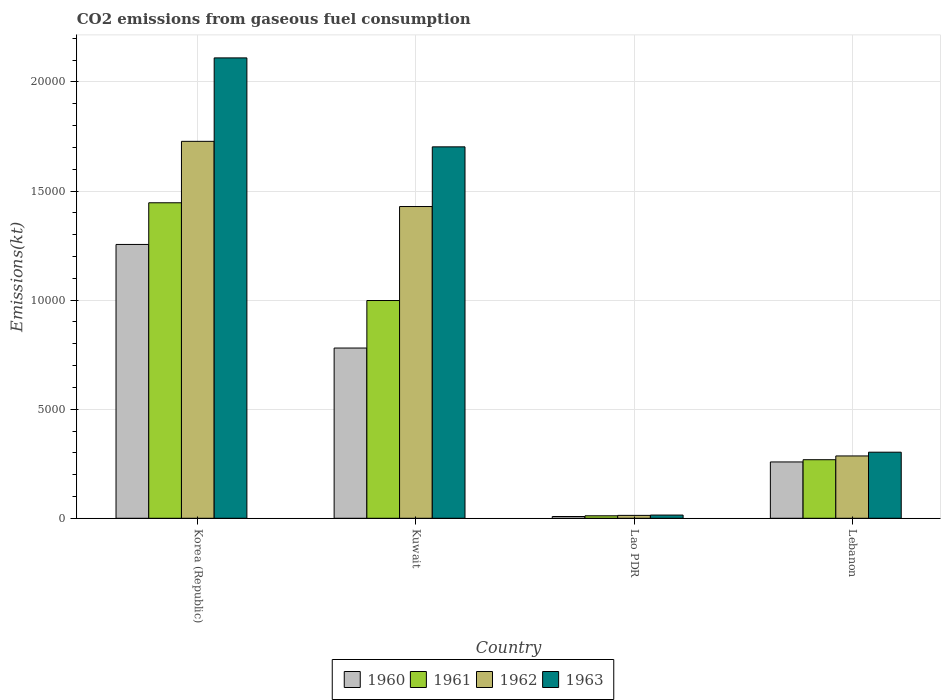How many bars are there on the 2nd tick from the left?
Keep it short and to the point. 4. What is the label of the 1st group of bars from the left?
Give a very brief answer. Korea (Republic). What is the amount of CO2 emitted in 1963 in Kuwait?
Ensure brevity in your answer.  1.70e+04. Across all countries, what is the maximum amount of CO2 emitted in 1963?
Provide a short and direct response. 2.11e+04. Across all countries, what is the minimum amount of CO2 emitted in 1962?
Keep it short and to the point. 132.01. In which country was the amount of CO2 emitted in 1963 maximum?
Keep it short and to the point. Korea (Republic). In which country was the amount of CO2 emitted in 1961 minimum?
Ensure brevity in your answer.  Lao PDR. What is the total amount of CO2 emitted in 1960 in the graph?
Keep it short and to the point. 2.30e+04. What is the difference between the amount of CO2 emitted in 1963 in Korea (Republic) and that in Kuwait?
Keep it short and to the point. 4077.7. What is the difference between the amount of CO2 emitted in 1960 in Kuwait and the amount of CO2 emitted in 1962 in Lebanon?
Offer a very short reply. 4946.78. What is the average amount of CO2 emitted in 1960 per country?
Give a very brief answer. 5754.44. What is the difference between the amount of CO2 emitted of/in 1963 and amount of CO2 emitted of/in 1962 in Lebanon?
Keep it short and to the point. 172.35. What is the ratio of the amount of CO2 emitted in 1961 in Kuwait to that in Lao PDR?
Provide a succinct answer. 87.81. What is the difference between the highest and the second highest amount of CO2 emitted in 1963?
Keep it short and to the point. 1.40e+04. What is the difference between the highest and the lowest amount of CO2 emitted in 1960?
Your response must be concise. 1.25e+04. In how many countries, is the amount of CO2 emitted in 1963 greater than the average amount of CO2 emitted in 1963 taken over all countries?
Provide a succinct answer. 2. Is the sum of the amount of CO2 emitted in 1960 in Korea (Republic) and Lao PDR greater than the maximum amount of CO2 emitted in 1963 across all countries?
Your response must be concise. No. Is it the case that in every country, the sum of the amount of CO2 emitted in 1963 and amount of CO2 emitted in 1962 is greater than the sum of amount of CO2 emitted in 1960 and amount of CO2 emitted in 1961?
Offer a very short reply. No. Is it the case that in every country, the sum of the amount of CO2 emitted in 1960 and amount of CO2 emitted in 1961 is greater than the amount of CO2 emitted in 1962?
Give a very brief answer. Yes. Are all the bars in the graph horizontal?
Provide a short and direct response. No. How many countries are there in the graph?
Make the answer very short. 4. Are the values on the major ticks of Y-axis written in scientific E-notation?
Provide a short and direct response. No. Does the graph contain any zero values?
Provide a short and direct response. No. How are the legend labels stacked?
Make the answer very short. Horizontal. What is the title of the graph?
Offer a terse response. CO2 emissions from gaseous fuel consumption. What is the label or title of the Y-axis?
Provide a succinct answer. Emissions(kt). What is the Emissions(kt) in 1960 in Korea (Republic)?
Keep it short and to the point. 1.26e+04. What is the Emissions(kt) of 1961 in Korea (Republic)?
Offer a very short reply. 1.45e+04. What is the Emissions(kt) in 1962 in Korea (Republic)?
Your response must be concise. 1.73e+04. What is the Emissions(kt) in 1963 in Korea (Republic)?
Ensure brevity in your answer.  2.11e+04. What is the Emissions(kt) in 1960 in Kuwait?
Your answer should be very brief. 7803.38. What is the Emissions(kt) of 1961 in Kuwait?
Provide a succinct answer. 9981.57. What is the Emissions(kt) in 1962 in Kuwait?
Give a very brief answer. 1.43e+04. What is the Emissions(kt) of 1963 in Kuwait?
Provide a short and direct response. 1.70e+04. What is the Emissions(kt) in 1960 in Lao PDR?
Make the answer very short. 80.67. What is the Emissions(kt) of 1961 in Lao PDR?
Your response must be concise. 113.68. What is the Emissions(kt) of 1962 in Lao PDR?
Ensure brevity in your answer.  132.01. What is the Emissions(kt) of 1963 in Lao PDR?
Make the answer very short. 146.68. What is the Emissions(kt) in 1960 in Lebanon?
Offer a terse response. 2581.57. What is the Emissions(kt) of 1961 in Lebanon?
Offer a terse response. 2684.24. What is the Emissions(kt) of 1962 in Lebanon?
Ensure brevity in your answer.  2856.59. What is the Emissions(kt) in 1963 in Lebanon?
Provide a short and direct response. 3028.94. Across all countries, what is the maximum Emissions(kt) in 1960?
Offer a terse response. 1.26e+04. Across all countries, what is the maximum Emissions(kt) of 1961?
Your answer should be compact. 1.45e+04. Across all countries, what is the maximum Emissions(kt) in 1962?
Your answer should be very brief. 1.73e+04. Across all countries, what is the maximum Emissions(kt) in 1963?
Your answer should be very brief. 2.11e+04. Across all countries, what is the minimum Emissions(kt) in 1960?
Ensure brevity in your answer.  80.67. Across all countries, what is the minimum Emissions(kt) in 1961?
Your answer should be compact. 113.68. Across all countries, what is the minimum Emissions(kt) in 1962?
Ensure brevity in your answer.  132.01. Across all countries, what is the minimum Emissions(kt) in 1963?
Offer a very short reply. 146.68. What is the total Emissions(kt) in 1960 in the graph?
Give a very brief answer. 2.30e+04. What is the total Emissions(kt) of 1961 in the graph?
Ensure brevity in your answer.  2.72e+04. What is the total Emissions(kt) in 1962 in the graph?
Give a very brief answer. 3.46e+04. What is the total Emissions(kt) in 1963 in the graph?
Your response must be concise. 4.13e+04. What is the difference between the Emissions(kt) of 1960 in Korea (Republic) and that in Kuwait?
Offer a very short reply. 4748.77. What is the difference between the Emissions(kt) in 1961 in Korea (Republic) and that in Kuwait?
Provide a short and direct response. 4481.07. What is the difference between the Emissions(kt) of 1962 in Korea (Republic) and that in Kuwait?
Provide a succinct answer. 2988.61. What is the difference between the Emissions(kt) in 1963 in Korea (Republic) and that in Kuwait?
Give a very brief answer. 4077.7. What is the difference between the Emissions(kt) of 1960 in Korea (Republic) and that in Lao PDR?
Offer a very short reply. 1.25e+04. What is the difference between the Emissions(kt) of 1961 in Korea (Republic) and that in Lao PDR?
Your answer should be very brief. 1.43e+04. What is the difference between the Emissions(kt) in 1962 in Korea (Republic) and that in Lao PDR?
Provide a succinct answer. 1.71e+04. What is the difference between the Emissions(kt) in 1963 in Korea (Republic) and that in Lao PDR?
Your answer should be very brief. 2.10e+04. What is the difference between the Emissions(kt) of 1960 in Korea (Republic) and that in Lebanon?
Give a very brief answer. 9970.57. What is the difference between the Emissions(kt) of 1961 in Korea (Republic) and that in Lebanon?
Ensure brevity in your answer.  1.18e+04. What is the difference between the Emissions(kt) of 1962 in Korea (Republic) and that in Lebanon?
Offer a very short reply. 1.44e+04. What is the difference between the Emissions(kt) in 1963 in Korea (Republic) and that in Lebanon?
Provide a succinct answer. 1.81e+04. What is the difference between the Emissions(kt) in 1960 in Kuwait and that in Lao PDR?
Make the answer very short. 7722.7. What is the difference between the Emissions(kt) in 1961 in Kuwait and that in Lao PDR?
Provide a succinct answer. 9867.9. What is the difference between the Emissions(kt) in 1962 in Kuwait and that in Lao PDR?
Offer a terse response. 1.42e+04. What is the difference between the Emissions(kt) of 1963 in Kuwait and that in Lao PDR?
Give a very brief answer. 1.69e+04. What is the difference between the Emissions(kt) in 1960 in Kuwait and that in Lebanon?
Give a very brief answer. 5221.81. What is the difference between the Emissions(kt) in 1961 in Kuwait and that in Lebanon?
Your response must be concise. 7297.33. What is the difference between the Emissions(kt) of 1962 in Kuwait and that in Lebanon?
Provide a short and direct response. 1.14e+04. What is the difference between the Emissions(kt) in 1963 in Kuwait and that in Lebanon?
Give a very brief answer. 1.40e+04. What is the difference between the Emissions(kt) of 1960 in Lao PDR and that in Lebanon?
Give a very brief answer. -2500.89. What is the difference between the Emissions(kt) in 1961 in Lao PDR and that in Lebanon?
Ensure brevity in your answer.  -2570.57. What is the difference between the Emissions(kt) of 1962 in Lao PDR and that in Lebanon?
Provide a succinct answer. -2724.58. What is the difference between the Emissions(kt) of 1963 in Lao PDR and that in Lebanon?
Provide a succinct answer. -2882.26. What is the difference between the Emissions(kt) in 1960 in Korea (Republic) and the Emissions(kt) in 1961 in Kuwait?
Offer a very short reply. 2570.57. What is the difference between the Emissions(kt) in 1960 in Korea (Republic) and the Emissions(kt) in 1962 in Kuwait?
Make the answer very short. -1738.16. What is the difference between the Emissions(kt) of 1960 in Korea (Republic) and the Emissions(kt) of 1963 in Kuwait?
Your answer should be very brief. -4473.74. What is the difference between the Emissions(kt) in 1961 in Korea (Republic) and the Emissions(kt) in 1962 in Kuwait?
Provide a short and direct response. 172.35. What is the difference between the Emissions(kt) of 1961 in Korea (Republic) and the Emissions(kt) of 1963 in Kuwait?
Your answer should be compact. -2563.23. What is the difference between the Emissions(kt) in 1962 in Korea (Republic) and the Emissions(kt) in 1963 in Kuwait?
Provide a short and direct response. 253.02. What is the difference between the Emissions(kt) of 1960 in Korea (Republic) and the Emissions(kt) of 1961 in Lao PDR?
Provide a succinct answer. 1.24e+04. What is the difference between the Emissions(kt) in 1960 in Korea (Republic) and the Emissions(kt) in 1962 in Lao PDR?
Provide a succinct answer. 1.24e+04. What is the difference between the Emissions(kt) of 1960 in Korea (Republic) and the Emissions(kt) of 1963 in Lao PDR?
Make the answer very short. 1.24e+04. What is the difference between the Emissions(kt) in 1961 in Korea (Republic) and the Emissions(kt) in 1962 in Lao PDR?
Your answer should be compact. 1.43e+04. What is the difference between the Emissions(kt) of 1961 in Korea (Republic) and the Emissions(kt) of 1963 in Lao PDR?
Make the answer very short. 1.43e+04. What is the difference between the Emissions(kt) in 1962 in Korea (Republic) and the Emissions(kt) in 1963 in Lao PDR?
Give a very brief answer. 1.71e+04. What is the difference between the Emissions(kt) of 1960 in Korea (Republic) and the Emissions(kt) of 1961 in Lebanon?
Ensure brevity in your answer.  9867.9. What is the difference between the Emissions(kt) in 1960 in Korea (Republic) and the Emissions(kt) in 1962 in Lebanon?
Give a very brief answer. 9695.55. What is the difference between the Emissions(kt) of 1960 in Korea (Republic) and the Emissions(kt) of 1963 in Lebanon?
Offer a very short reply. 9523.2. What is the difference between the Emissions(kt) in 1961 in Korea (Republic) and the Emissions(kt) in 1962 in Lebanon?
Provide a short and direct response. 1.16e+04. What is the difference between the Emissions(kt) in 1961 in Korea (Republic) and the Emissions(kt) in 1963 in Lebanon?
Keep it short and to the point. 1.14e+04. What is the difference between the Emissions(kt) in 1962 in Korea (Republic) and the Emissions(kt) in 1963 in Lebanon?
Keep it short and to the point. 1.42e+04. What is the difference between the Emissions(kt) in 1960 in Kuwait and the Emissions(kt) in 1961 in Lao PDR?
Offer a terse response. 7689.7. What is the difference between the Emissions(kt) in 1960 in Kuwait and the Emissions(kt) in 1962 in Lao PDR?
Your response must be concise. 7671.36. What is the difference between the Emissions(kt) of 1960 in Kuwait and the Emissions(kt) of 1963 in Lao PDR?
Make the answer very short. 7656.7. What is the difference between the Emissions(kt) in 1961 in Kuwait and the Emissions(kt) in 1962 in Lao PDR?
Your answer should be compact. 9849.56. What is the difference between the Emissions(kt) in 1961 in Kuwait and the Emissions(kt) in 1963 in Lao PDR?
Your response must be concise. 9834.89. What is the difference between the Emissions(kt) of 1962 in Kuwait and the Emissions(kt) of 1963 in Lao PDR?
Provide a succinct answer. 1.41e+04. What is the difference between the Emissions(kt) in 1960 in Kuwait and the Emissions(kt) in 1961 in Lebanon?
Offer a very short reply. 5119.13. What is the difference between the Emissions(kt) in 1960 in Kuwait and the Emissions(kt) in 1962 in Lebanon?
Keep it short and to the point. 4946.78. What is the difference between the Emissions(kt) of 1960 in Kuwait and the Emissions(kt) of 1963 in Lebanon?
Give a very brief answer. 4774.43. What is the difference between the Emissions(kt) of 1961 in Kuwait and the Emissions(kt) of 1962 in Lebanon?
Offer a very short reply. 7124.98. What is the difference between the Emissions(kt) of 1961 in Kuwait and the Emissions(kt) of 1963 in Lebanon?
Make the answer very short. 6952.63. What is the difference between the Emissions(kt) in 1962 in Kuwait and the Emissions(kt) in 1963 in Lebanon?
Provide a short and direct response. 1.13e+04. What is the difference between the Emissions(kt) in 1960 in Lao PDR and the Emissions(kt) in 1961 in Lebanon?
Make the answer very short. -2603.57. What is the difference between the Emissions(kt) in 1960 in Lao PDR and the Emissions(kt) in 1962 in Lebanon?
Provide a short and direct response. -2775.92. What is the difference between the Emissions(kt) of 1960 in Lao PDR and the Emissions(kt) of 1963 in Lebanon?
Offer a terse response. -2948.27. What is the difference between the Emissions(kt) of 1961 in Lao PDR and the Emissions(kt) of 1962 in Lebanon?
Offer a terse response. -2742.92. What is the difference between the Emissions(kt) of 1961 in Lao PDR and the Emissions(kt) of 1963 in Lebanon?
Provide a short and direct response. -2915.26. What is the difference between the Emissions(kt) of 1962 in Lao PDR and the Emissions(kt) of 1963 in Lebanon?
Provide a succinct answer. -2896.93. What is the average Emissions(kt) of 1960 per country?
Your answer should be very brief. 5754.44. What is the average Emissions(kt) in 1961 per country?
Make the answer very short. 6810.54. What is the average Emissions(kt) of 1962 per country?
Provide a short and direct response. 8639.45. What is the average Emissions(kt) in 1963 per country?
Ensure brevity in your answer.  1.03e+04. What is the difference between the Emissions(kt) in 1960 and Emissions(kt) in 1961 in Korea (Republic)?
Your answer should be very brief. -1910.51. What is the difference between the Emissions(kt) in 1960 and Emissions(kt) in 1962 in Korea (Republic)?
Provide a succinct answer. -4726.76. What is the difference between the Emissions(kt) of 1960 and Emissions(kt) of 1963 in Korea (Republic)?
Make the answer very short. -8551.44. What is the difference between the Emissions(kt) in 1961 and Emissions(kt) in 1962 in Korea (Republic)?
Provide a short and direct response. -2816.26. What is the difference between the Emissions(kt) in 1961 and Emissions(kt) in 1963 in Korea (Republic)?
Ensure brevity in your answer.  -6640.94. What is the difference between the Emissions(kt) in 1962 and Emissions(kt) in 1963 in Korea (Republic)?
Your answer should be very brief. -3824.68. What is the difference between the Emissions(kt) in 1960 and Emissions(kt) in 1961 in Kuwait?
Your response must be concise. -2178.2. What is the difference between the Emissions(kt) of 1960 and Emissions(kt) of 1962 in Kuwait?
Ensure brevity in your answer.  -6486.92. What is the difference between the Emissions(kt) of 1960 and Emissions(kt) of 1963 in Kuwait?
Make the answer very short. -9222.5. What is the difference between the Emissions(kt) of 1961 and Emissions(kt) of 1962 in Kuwait?
Your answer should be compact. -4308.73. What is the difference between the Emissions(kt) of 1961 and Emissions(kt) of 1963 in Kuwait?
Offer a terse response. -7044.31. What is the difference between the Emissions(kt) in 1962 and Emissions(kt) in 1963 in Kuwait?
Offer a very short reply. -2735.58. What is the difference between the Emissions(kt) in 1960 and Emissions(kt) in 1961 in Lao PDR?
Your answer should be very brief. -33. What is the difference between the Emissions(kt) in 1960 and Emissions(kt) in 1962 in Lao PDR?
Your answer should be compact. -51.34. What is the difference between the Emissions(kt) in 1960 and Emissions(kt) in 1963 in Lao PDR?
Make the answer very short. -66.01. What is the difference between the Emissions(kt) of 1961 and Emissions(kt) of 1962 in Lao PDR?
Keep it short and to the point. -18.34. What is the difference between the Emissions(kt) of 1961 and Emissions(kt) of 1963 in Lao PDR?
Make the answer very short. -33. What is the difference between the Emissions(kt) of 1962 and Emissions(kt) of 1963 in Lao PDR?
Your answer should be compact. -14.67. What is the difference between the Emissions(kt) in 1960 and Emissions(kt) in 1961 in Lebanon?
Give a very brief answer. -102.68. What is the difference between the Emissions(kt) of 1960 and Emissions(kt) of 1962 in Lebanon?
Your response must be concise. -275.02. What is the difference between the Emissions(kt) in 1960 and Emissions(kt) in 1963 in Lebanon?
Ensure brevity in your answer.  -447.37. What is the difference between the Emissions(kt) in 1961 and Emissions(kt) in 1962 in Lebanon?
Provide a short and direct response. -172.35. What is the difference between the Emissions(kt) in 1961 and Emissions(kt) in 1963 in Lebanon?
Make the answer very short. -344.7. What is the difference between the Emissions(kt) in 1962 and Emissions(kt) in 1963 in Lebanon?
Ensure brevity in your answer.  -172.35. What is the ratio of the Emissions(kt) of 1960 in Korea (Republic) to that in Kuwait?
Your response must be concise. 1.61. What is the ratio of the Emissions(kt) of 1961 in Korea (Republic) to that in Kuwait?
Keep it short and to the point. 1.45. What is the ratio of the Emissions(kt) in 1962 in Korea (Republic) to that in Kuwait?
Offer a very short reply. 1.21. What is the ratio of the Emissions(kt) in 1963 in Korea (Republic) to that in Kuwait?
Give a very brief answer. 1.24. What is the ratio of the Emissions(kt) of 1960 in Korea (Republic) to that in Lao PDR?
Your response must be concise. 155.59. What is the ratio of the Emissions(kt) of 1961 in Korea (Republic) to that in Lao PDR?
Offer a very short reply. 127.23. What is the ratio of the Emissions(kt) in 1962 in Korea (Republic) to that in Lao PDR?
Your response must be concise. 130.89. What is the ratio of the Emissions(kt) in 1963 in Korea (Republic) to that in Lao PDR?
Your answer should be very brief. 143.88. What is the ratio of the Emissions(kt) in 1960 in Korea (Republic) to that in Lebanon?
Provide a succinct answer. 4.86. What is the ratio of the Emissions(kt) in 1961 in Korea (Republic) to that in Lebanon?
Your response must be concise. 5.39. What is the ratio of the Emissions(kt) in 1962 in Korea (Republic) to that in Lebanon?
Your answer should be very brief. 6.05. What is the ratio of the Emissions(kt) of 1963 in Korea (Republic) to that in Lebanon?
Your answer should be very brief. 6.97. What is the ratio of the Emissions(kt) of 1960 in Kuwait to that in Lao PDR?
Your response must be concise. 96.73. What is the ratio of the Emissions(kt) in 1961 in Kuwait to that in Lao PDR?
Offer a very short reply. 87.81. What is the ratio of the Emissions(kt) of 1962 in Kuwait to that in Lao PDR?
Ensure brevity in your answer.  108.25. What is the ratio of the Emissions(kt) in 1963 in Kuwait to that in Lao PDR?
Offer a very short reply. 116.08. What is the ratio of the Emissions(kt) in 1960 in Kuwait to that in Lebanon?
Give a very brief answer. 3.02. What is the ratio of the Emissions(kt) in 1961 in Kuwait to that in Lebanon?
Make the answer very short. 3.72. What is the ratio of the Emissions(kt) in 1962 in Kuwait to that in Lebanon?
Make the answer very short. 5. What is the ratio of the Emissions(kt) of 1963 in Kuwait to that in Lebanon?
Your answer should be compact. 5.62. What is the ratio of the Emissions(kt) in 1960 in Lao PDR to that in Lebanon?
Your response must be concise. 0.03. What is the ratio of the Emissions(kt) of 1961 in Lao PDR to that in Lebanon?
Your answer should be compact. 0.04. What is the ratio of the Emissions(kt) in 1962 in Lao PDR to that in Lebanon?
Ensure brevity in your answer.  0.05. What is the ratio of the Emissions(kt) of 1963 in Lao PDR to that in Lebanon?
Make the answer very short. 0.05. What is the difference between the highest and the second highest Emissions(kt) in 1960?
Your response must be concise. 4748.77. What is the difference between the highest and the second highest Emissions(kt) of 1961?
Offer a very short reply. 4481.07. What is the difference between the highest and the second highest Emissions(kt) of 1962?
Provide a short and direct response. 2988.61. What is the difference between the highest and the second highest Emissions(kt) in 1963?
Your answer should be very brief. 4077.7. What is the difference between the highest and the lowest Emissions(kt) in 1960?
Your response must be concise. 1.25e+04. What is the difference between the highest and the lowest Emissions(kt) of 1961?
Your response must be concise. 1.43e+04. What is the difference between the highest and the lowest Emissions(kt) of 1962?
Offer a very short reply. 1.71e+04. What is the difference between the highest and the lowest Emissions(kt) in 1963?
Make the answer very short. 2.10e+04. 